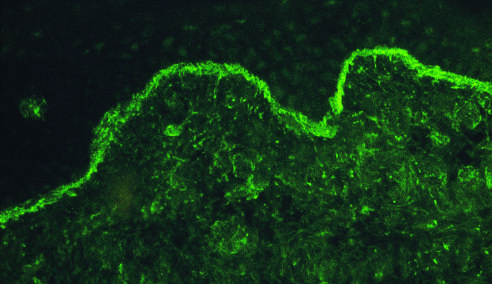what reveals deposits of ig along the dermo-epidermal junction?
Answer the question using a single word or phrase. An immunofluorescence micrograph stained for igg 